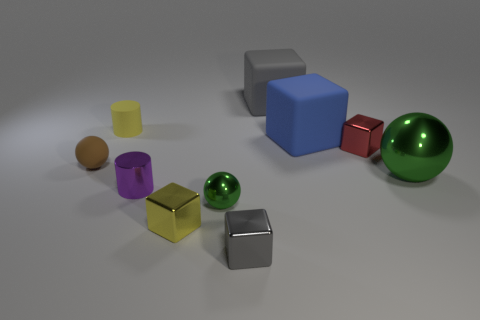Is the small red cube made of the same material as the blue thing?
Your response must be concise. No. How many large blue cubes are the same material as the purple cylinder?
Offer a very short reply. 0. Is the size of the blue matte cube the same as the green ball that is on the right side of the big gray matte cube?
Offer a terse response. Yes. What is the color of the metal thing that is in front of the red cube and right of the large blue rubber block?
Give a very brief answer. Green. There is a gray block in front of the small purple cylinder; is there a tiny green ball that is right of it?
Keep it short and to the point. No. Are there an equal number of big blocks to the right of the large metal ball and gray blocks?
Your answer should be compact. No. There is a green thing that is behind the small metal object left of the yellow metallic block; what number of tiny matte objects are behind it?
Keep it short and to the point. 2. Is there a green metal ball that has the same size as the matte cylinder?
Your response must be concise. Yes. Is the number of small green metal objects to the left of the brown rubber ball less than the number of gray shiny cylinders?
Your response must be concise. No. There is a green ball behind the green object in front of the large green sphere on the right side of the big gray thing; what is its material?
Offer a terse response. Metal. 